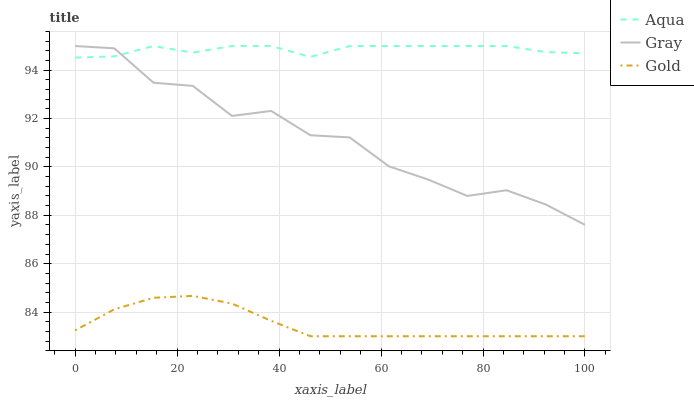Does Aqua have the minimum area under the curve?
Answer yes or no. No. Does Gold have the maximum area under the curve?
Answer yes or no. No. Is Aqua the smoothest?
Answer yes or no. No. Is Aqua the roughest?
Answer yes or no. No. Does Aqua have the lowest value?
Answer yes or no. No. Does Gold have the highest value?
Answer yes or no. No. Is Gold less than Gray?
Answer yes or no. Yes. Is Aqua greater than Gold?
Answer yes or no. Yes. Does Gold intersect Gray?
Answer yes or no. No. 